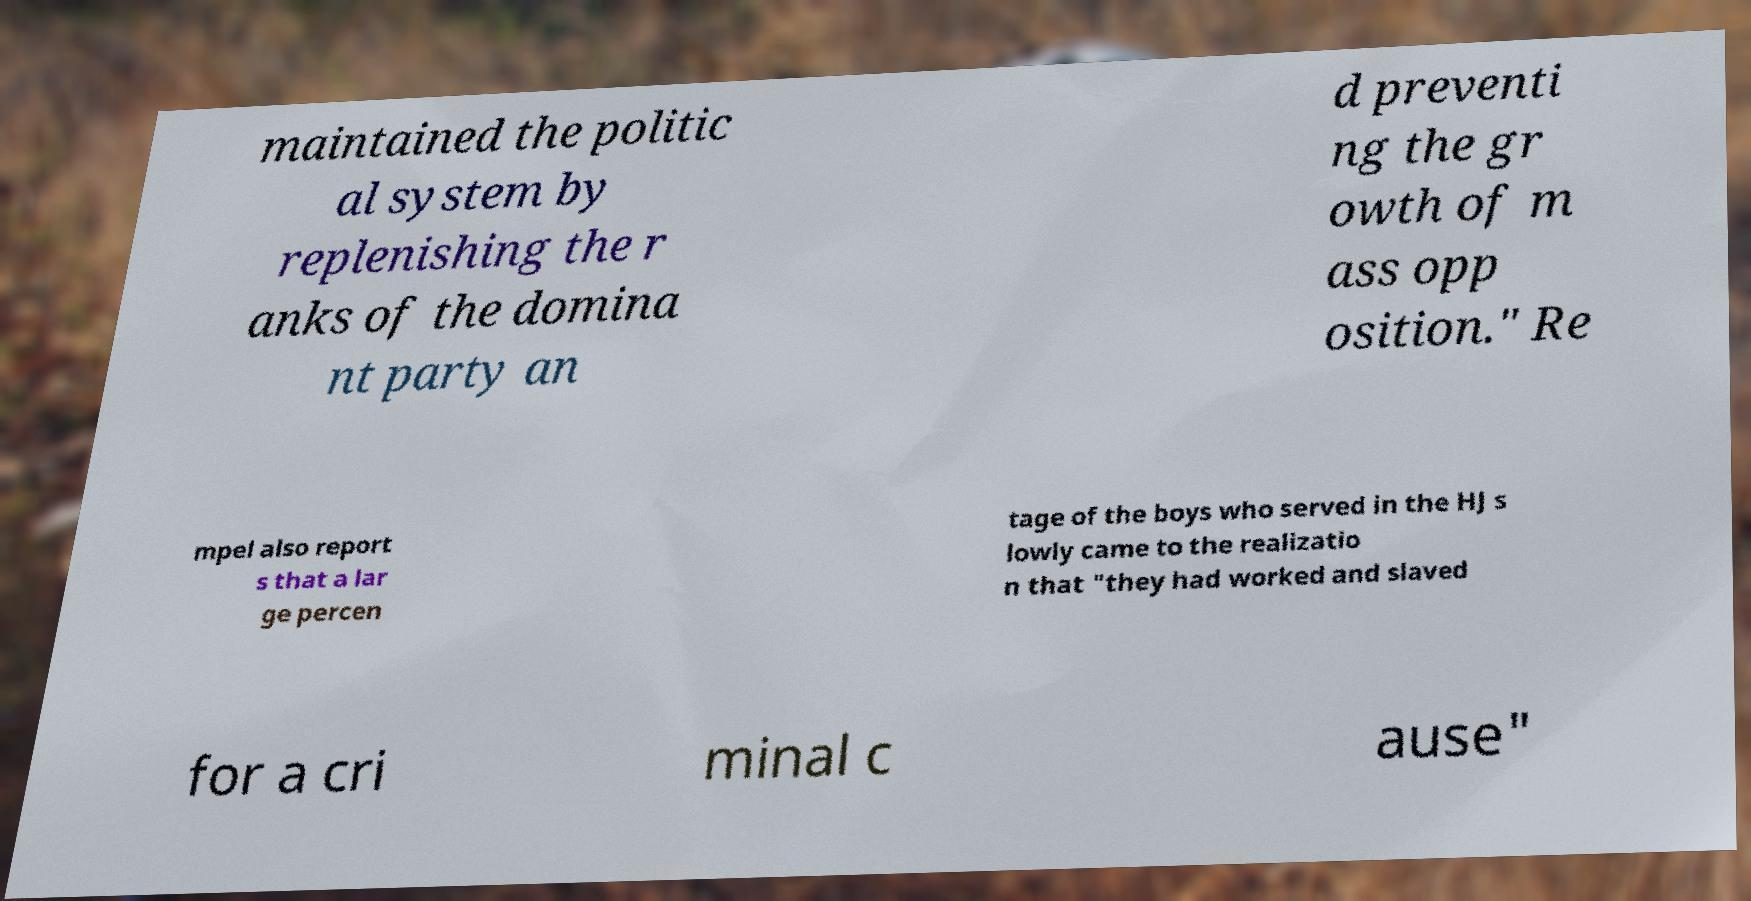Could you extract and type out the text from this image? maintained the politic al system by replenishing the r anks of the domina nt party an d preventi ng the gr owth of m ass opp osition." Re mpel also report s that a lar ge percen tage of the boys who served in the HJ s lowly came to the realizatio n that "they had worked and slaved for a cri minal c ause" 